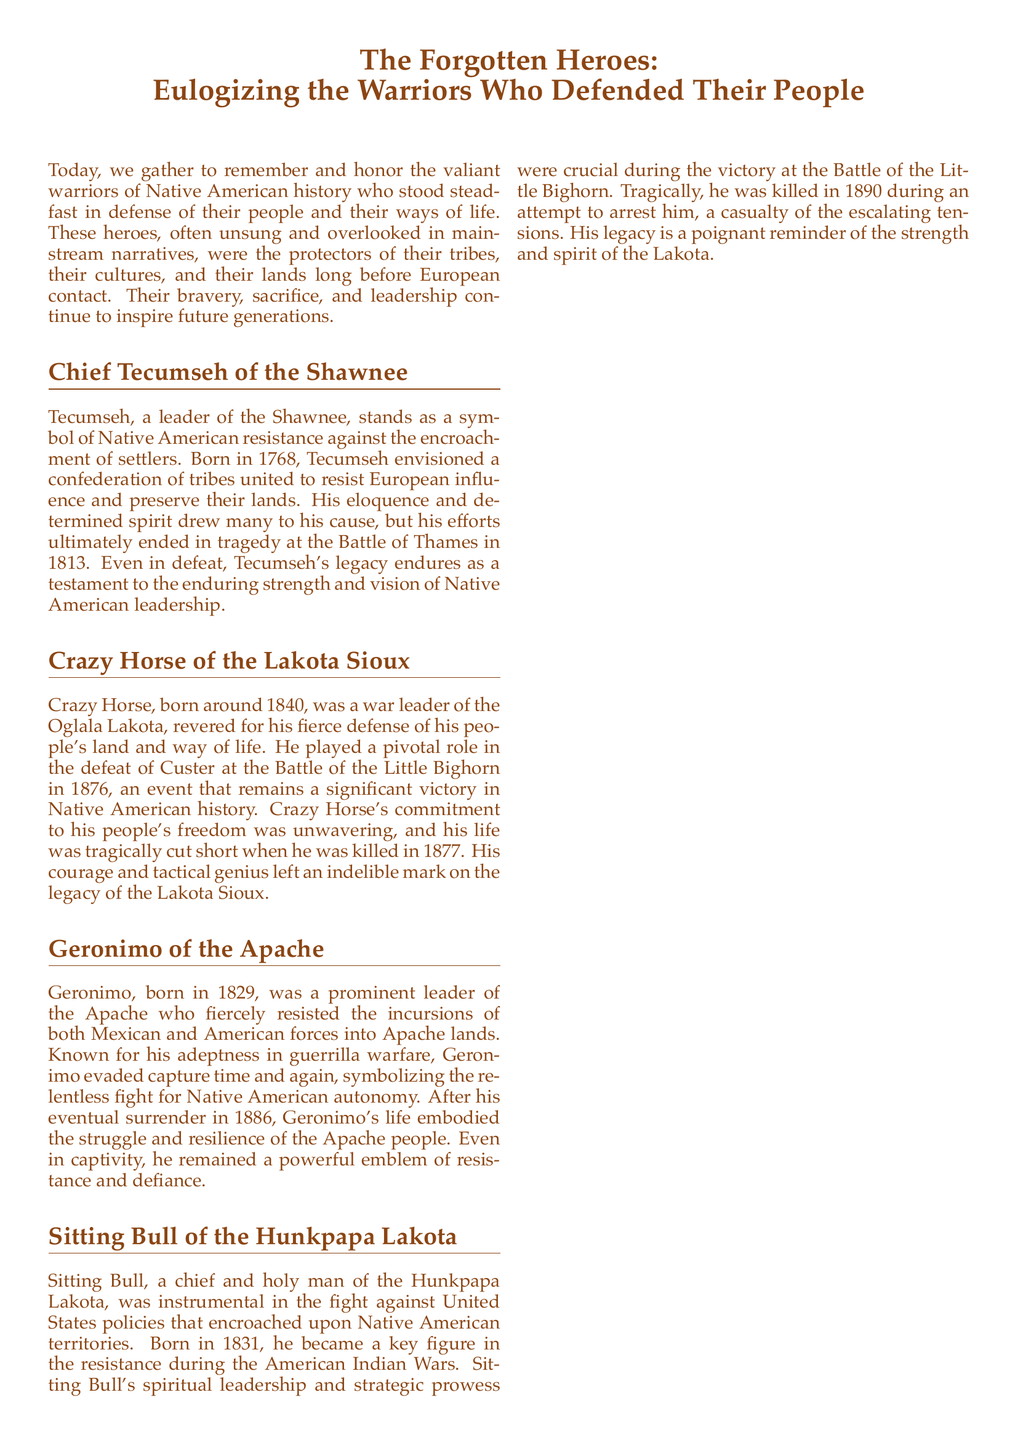What is the title of the document? The title of the document states the main focus of the eulogy, which is on the forgotten heroes of Native American history.
Answer: The Forgotten Heroes: Eulogizing the Warriors Who Defended Their People Who was the leader of the Shawnee? This question is based on the specific individual mentioned in the document under the section about the Shawnee.
Answer: Chief Tecumseh In what year was Chief Tecumseh born? The document provides the birth year of Tecumseh, which highlights his historical context.
Answer: 1768 What significant battle did Crazy Horse lead in? This reflects the specific event mentioned in the narrative about Crazy Horse.
Answer: Battle of the Little Bighorn What year did Geronimo surrender? This question asks for a specific date related to the Apache leader's resistance.
Answer: 1886 What role did Sitting Bull play in the resistance? This requires understanding the contributions credited to Sitting Bull in the document.
Answer: Chief and holy man Why is Crazy Horse considered a pivotal figure in Native American history? This asks for reasoning about Crazy Horse’s impact during a major battle and his qualities that mark him as significant.
Answer: He played a pivotal role in the defeat of Custer What theme is emphasized in the conclusion of the document? This question addresses the overarching message conveyed at the end of the eulogy.
Answer: Resistance and resilience What was Geronimo known for? This focuses on the notable attribute or skill associated with Geronimo as described in the text.
Answer: Guerrilla warfare 